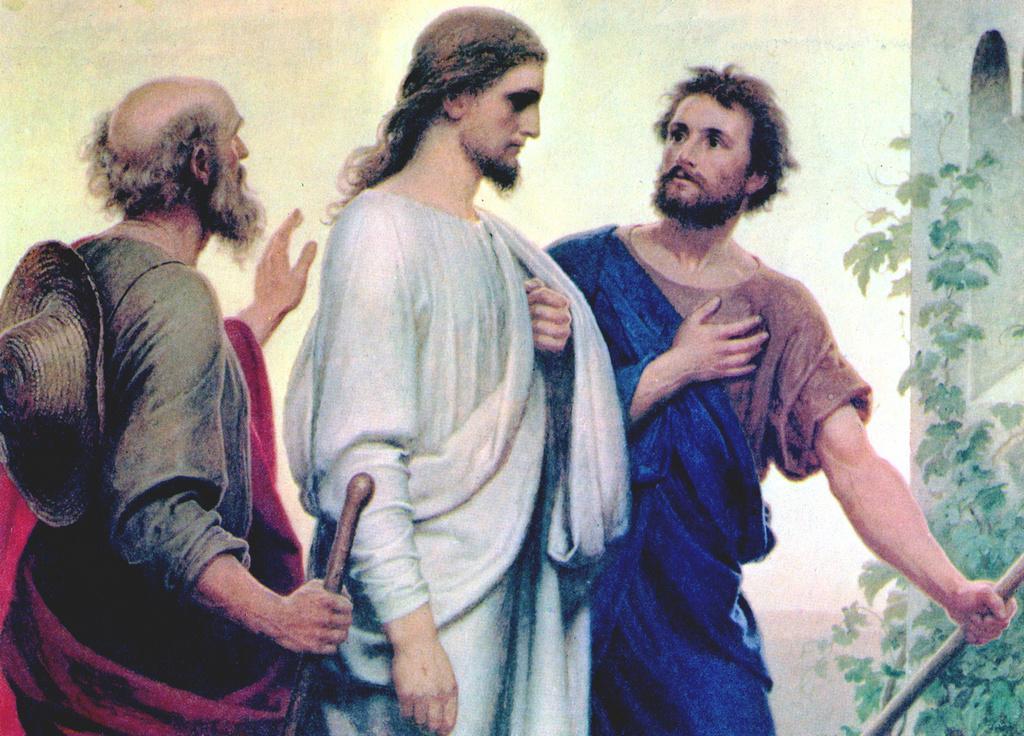How would you summarize this image in a sentence or two? The picture is an animation. In the picture there are three persons. On the left there is a person holding stick and wearing a hat. In the center the person is wearing a white dress. On the right there is a tree and wall. 